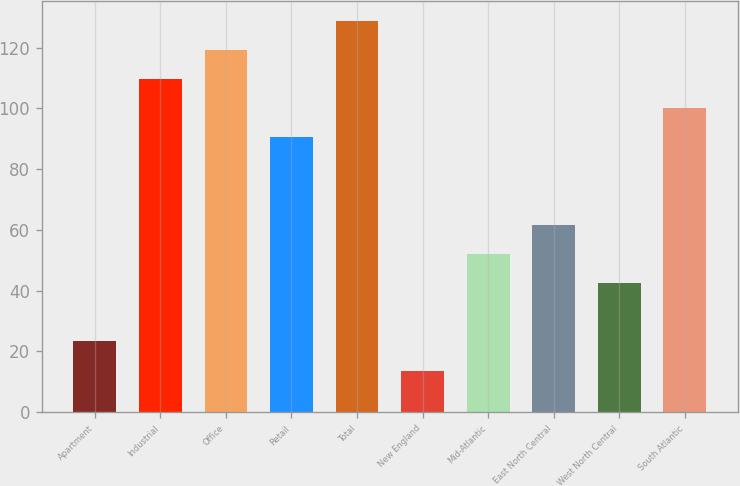Convert chart to OTSL. <chart><loc_0><loc_0><loc_500><loc_500><bar_chart><fcel>Apartment<fcel>Industrial<fcel>Office<fcel>Retail<fcel>Total<fcel>New England<fcel>Mid-Atlantic<fcel>East North Central<fcel>West North Central<fcel>South Atlantic<nl><fcel>23.28<fcel>109.59<fcel>119.18<fcel>90.41<fcel>128.77<fcel>13.69<fcel>52.05<fcel>61.64<fcel>42.46<fcel>100<nl></chart> 